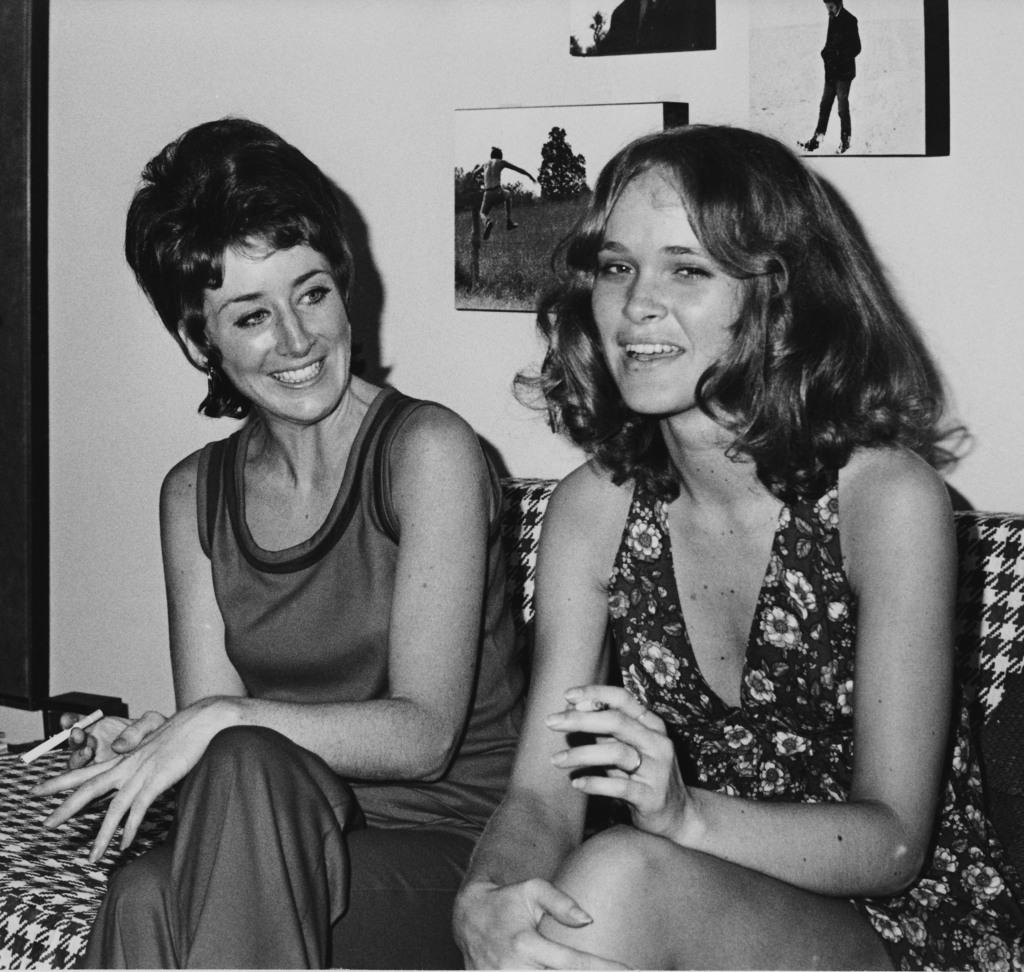How many people are sitting on the couch in the image? There are two people sitting on the couch in the image. What is one person holding in the image? One person is holding something in the image. What can be seen on the wall in the image? There are frames attached to the wall in the image. What is the color scheme of the image? The image is in black and white. Is the woman playing basketball with the bag in the image? There is no woman, basketball, or bag present in the image. 